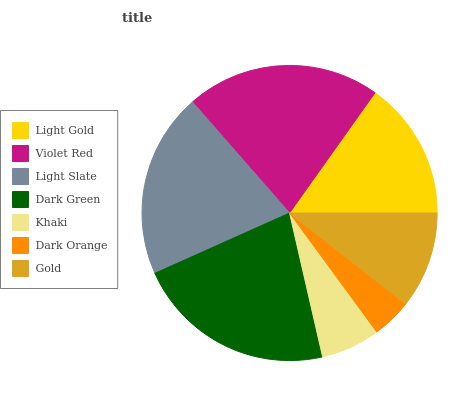Is Dark Orange the minimum?
Answer yes or no. Yes. Is Dark Green the maximum?
Answer yes or no. Yes. Is Violet Red the minimum?
Answer yes or no. No. Is Violet Red the maximum?
Answer yes or no. No. Is Violet Red greater than Light Gold?
Answer yes or no. Yes. Is Light Gold less than Violet Red?
Answer yes or no. Yes. Is Light Gold greater than Violet Red?
Answer yes or no. No. Is Violet Red less than Light Gold?
Answer yes or no. No. Is Light Gold the high median?
Answer yes or no. Yes. Is Light Gold the low median?
Answer yes or no. Yes. Is Gold the high median?
Answer yes or no. No. Is Dark Orange the low median?
Answer yes or no. No. 